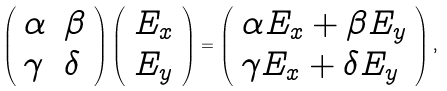<formula> <loc_0><loc_0><loc_500><loc_500>\left ( \begin{array} { l l } { \alpha } & { \beta } \\ { \gamma } & { \delta } \end{array} \right ) \left ( \begin{array} { l } { { E _ { x } } } \\ { { E _ { y } } } \end{array} \right ) = \left ( \begin{array} { l } { { \alpha E _ { x } + \beta E _ { y } } } \\ { { \gamma E _ { x } + \delta E _ { y } } } \end{array} \right ) ,</formula> 